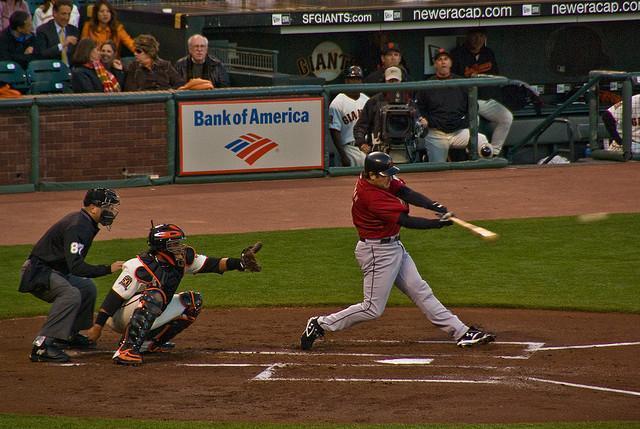How many people can you see?
Give a very brief answer. 8. How many knives are shown in the picture?
Give a very brief answer. 0. 